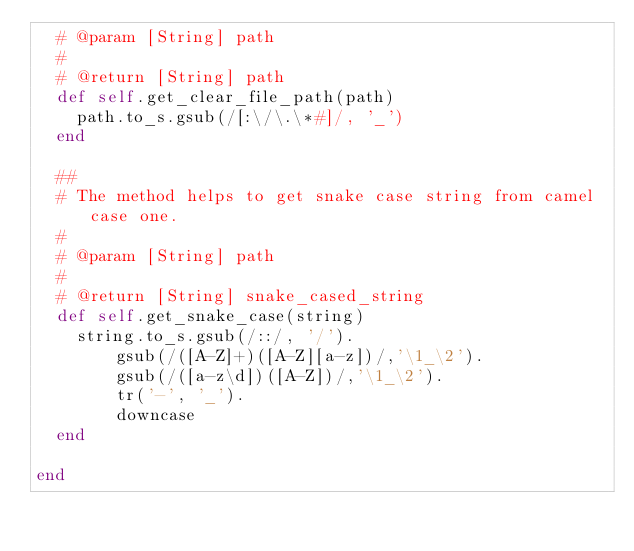Convert code to text. <code><loc_0><loc_0><loc_500><loc_500><_Ruby_>  # @param [String] path
  #
  # @return [String] path
  def self.get_clear_file_path(path)
    path.to_s.gsub(/[:\/\.\*#]/, '_')
  end

  ##
  # The method helps to get snake case string from camel case one.
  #
  # @param [String] path
  #
  # @return [String] snake_cased_string
  def self.get_snake_case(string)
    string.to_s.gsub(/::/, '/').
        gsub(/([A-Z]+)([A-Z][a-z])/,'\1_\2').
        gsub(/([a-z\d])([A-Z])/,'\1_\2').
        tr('-', '_').
        downcase
  end

end</code> 